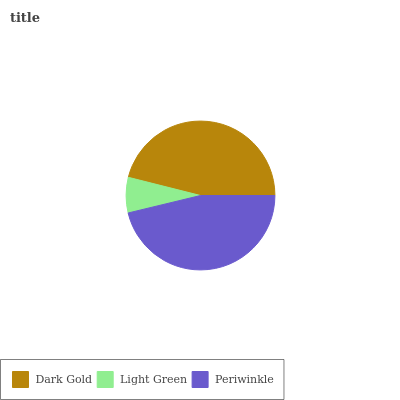Is Light Green the minimum?
Answer yes or no. Yes. Is Periwinkle the maximum?
Answer yes or no. Yes. Is Periwinkle the minimum?
Answer yes or no. No. Is Light Green the maximum?
Answer yes or no. No. Is Periwinkle greater than Light Green?
Answer yes or no. Yes. Is Light Green less than Periwinkle?
Answer yes or no. Yes. Is Light Green greater than Periwinkle?
Answer yes or no. No. Is Periwinkle less than Light Green?
Answer yes or no. No. Is Dark Gold the high median?
Answer yes or no. Yes. Is Dark Gold the low median?
Answer yes or no. Yes. Is Light Green the high median?
Answer yes or no. No. Is Light Green the low median?
Answer yes or no. No. 